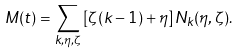Convert formula to latex. <formula><loc_0><loc_0><loc_500><loc_500>M ( t ) = \sum _ { k , \eta , \zeta } \left [ \zeta ( k - 1 ) + \eta \right ] N _ { k } ( \eta , \zeta ) .</formula> 